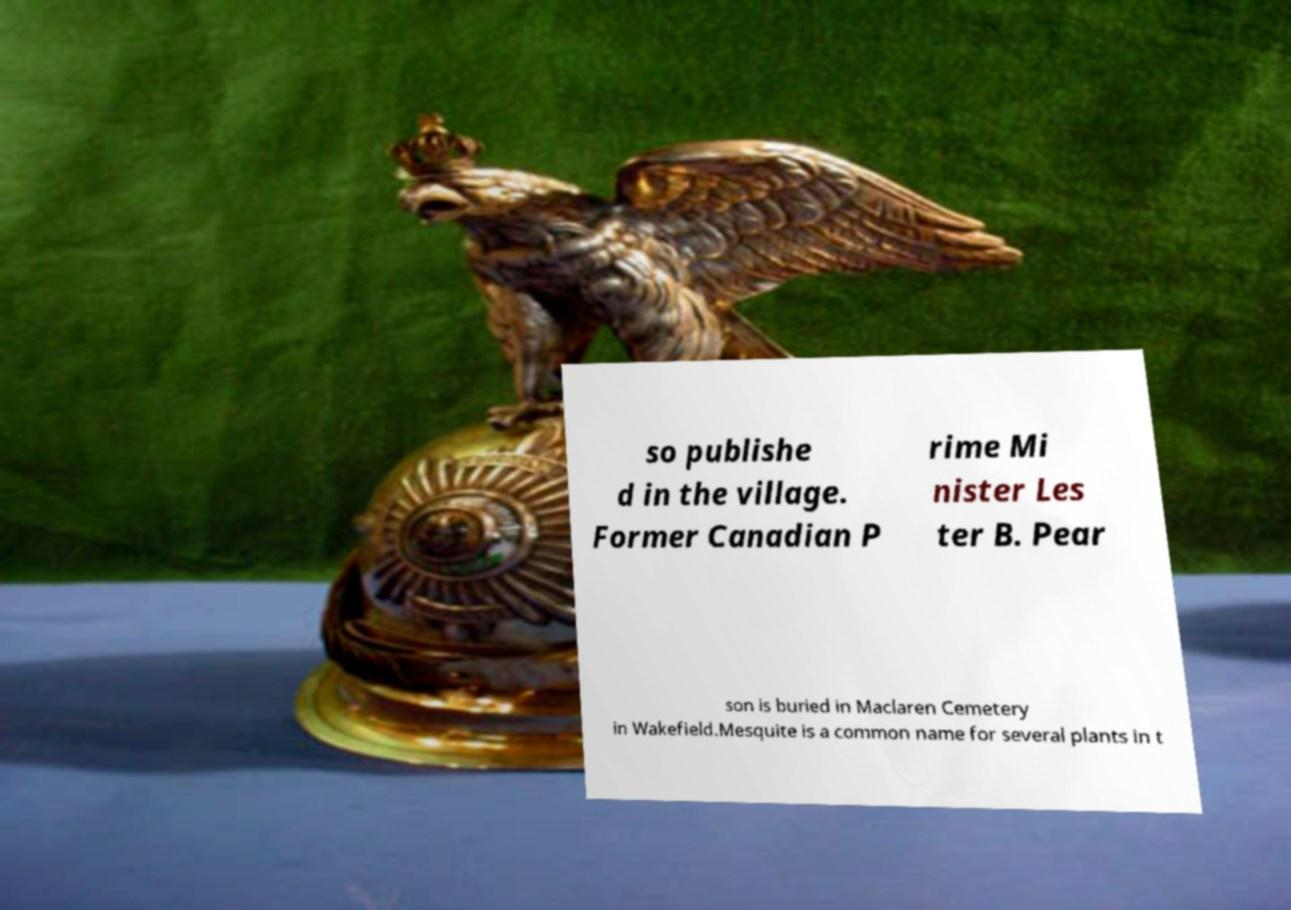Can you read and provide the text displayed in the image?This photo seems to have some interesting text. Can you extract and type it out for me? so publishe d in the village. Former Canadian P rime Mi nister Les ter B. Pear son is buried in Maclaren Cemetery in Wakefield.Mesquite is a common name for several plants in t 